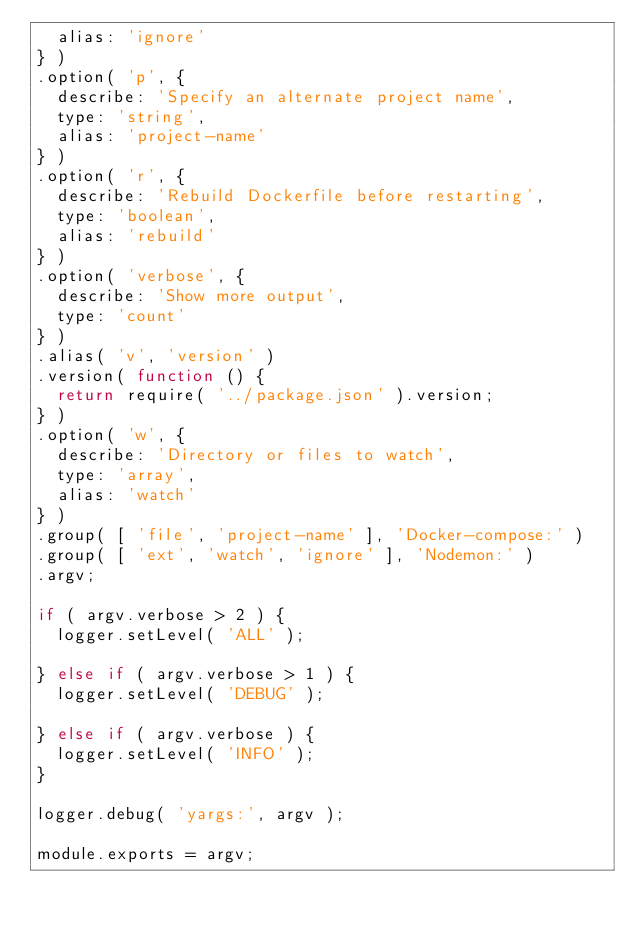Convert code to text. <code><loc_0><loc_0><loc_500><loc_500><_JavaScript_>  alias: 'ignore'
} )
.option( 'p', {
  describe: 'Specify an alternate project name',
  type: 'string',
  alias: 'project-name'
} )
.option( 'r', {
  describe: 'Rebuild Dockerfile before restarting',
  type: 'boolean',
  alias: 'rebuild'
} )
.option( 'verbose', {
  describe: 'Show more output',
  type: 'count'
} )
.alias( 'v', 'version' )
.version( function () {
  return require( '../package.json' ).version;
} )
.option( 'w', {
  describe: 'Directory or files to watch',
  type: 'array',
  alias: 'watch'
} )
.group( [ 'file', 'project-name' ], 'Docker-compose:' )
.group( [ 'ext', 'watch', 'ignore' ], 'Nodemon:' )
.argv;

if ( argv.verbose > 2 ) {
  logger.setLevel( 'ALL' );

} else if ( argv.verbose > 1 ) {
  logger.setLevel( 'DEBUG' );

} else if ( argv.verbose ) {
  logger.setLevel( 'INFO' );
}

logger.debug( 'yargs:', argv );

module.exports = argv;
</code> 